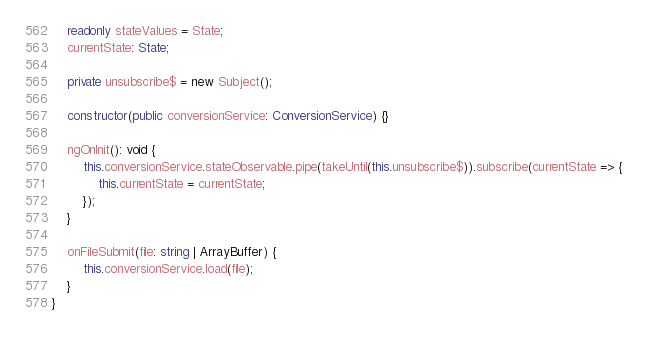<code> <loc_0><loc_0><loc_500><loc_500><_TypeScript_>    readonly stateValues = State;
    currentState: State;

    private unsubscribe$ = new Subject();

    constructor(public conversionService: ConversionService) {}

    ngOnInit(): void {
        this.conversionService.stateObservable.pipe(takeUntil(this.unsubscribe$)).subscribe(currentState => {
            this.currentState = currentState;
        });
    }

    onFileSubmit(file: string | ArrayBuffer) {
        this.conversionService.load(file);
    }
}
</code> 